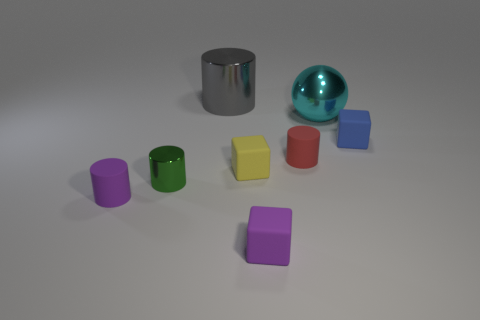Subtract all tiny purple matte blocks. How many blocks are left? 2 Add 1 purple rubber things. How many objects exist? 9 Subtract 1 blocks. How many blocks are left? 2 Subtract all blue cubes. How many cubes are left? 2 Subtract all blocks. How many objects are left? 5 Add 4 tiny red cylinders. How many tiny red cylinders are left? 5 Add 8 green balls. How many green balls exist? 8 Subtract 0 red blocks. How many objects are left? 8 Subtract all green cylinders. Subtract all cyan spheres. How many cylinders are left? 3 Subtract all tiny blue rubber cylinders. Subtract all small blue rubber cubes. How many objects are left? 7 